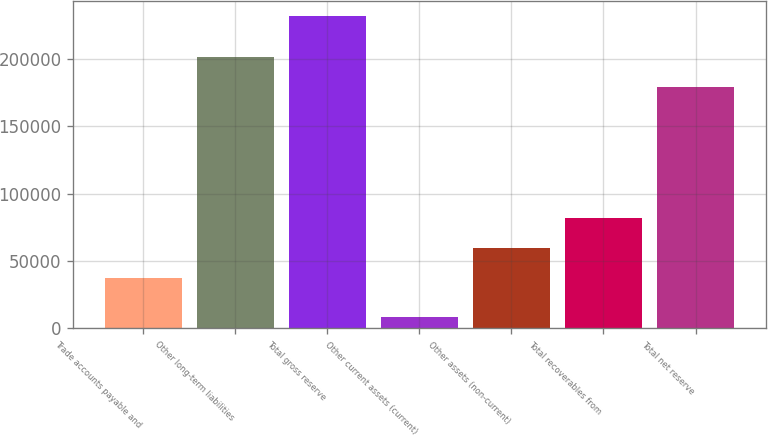Convert chart to OTSL. <chart><loc_0><loc_0><loc_500><loc_500><bar_chart><fcel>Trade accounts payable and<fcel>Other long-term liabilities<fcel>Total gross reserve<fcel>Other current assets (current)<fcel>Other assets (non-current)<fcel>Total recoverables from<fcel>Total net reserve<nl><fcel>37619<fcel>201376<fcel>231494<fcel>8441<fcel>59924.3<fcel>82229.6<fcel>179071<nl></chart> 